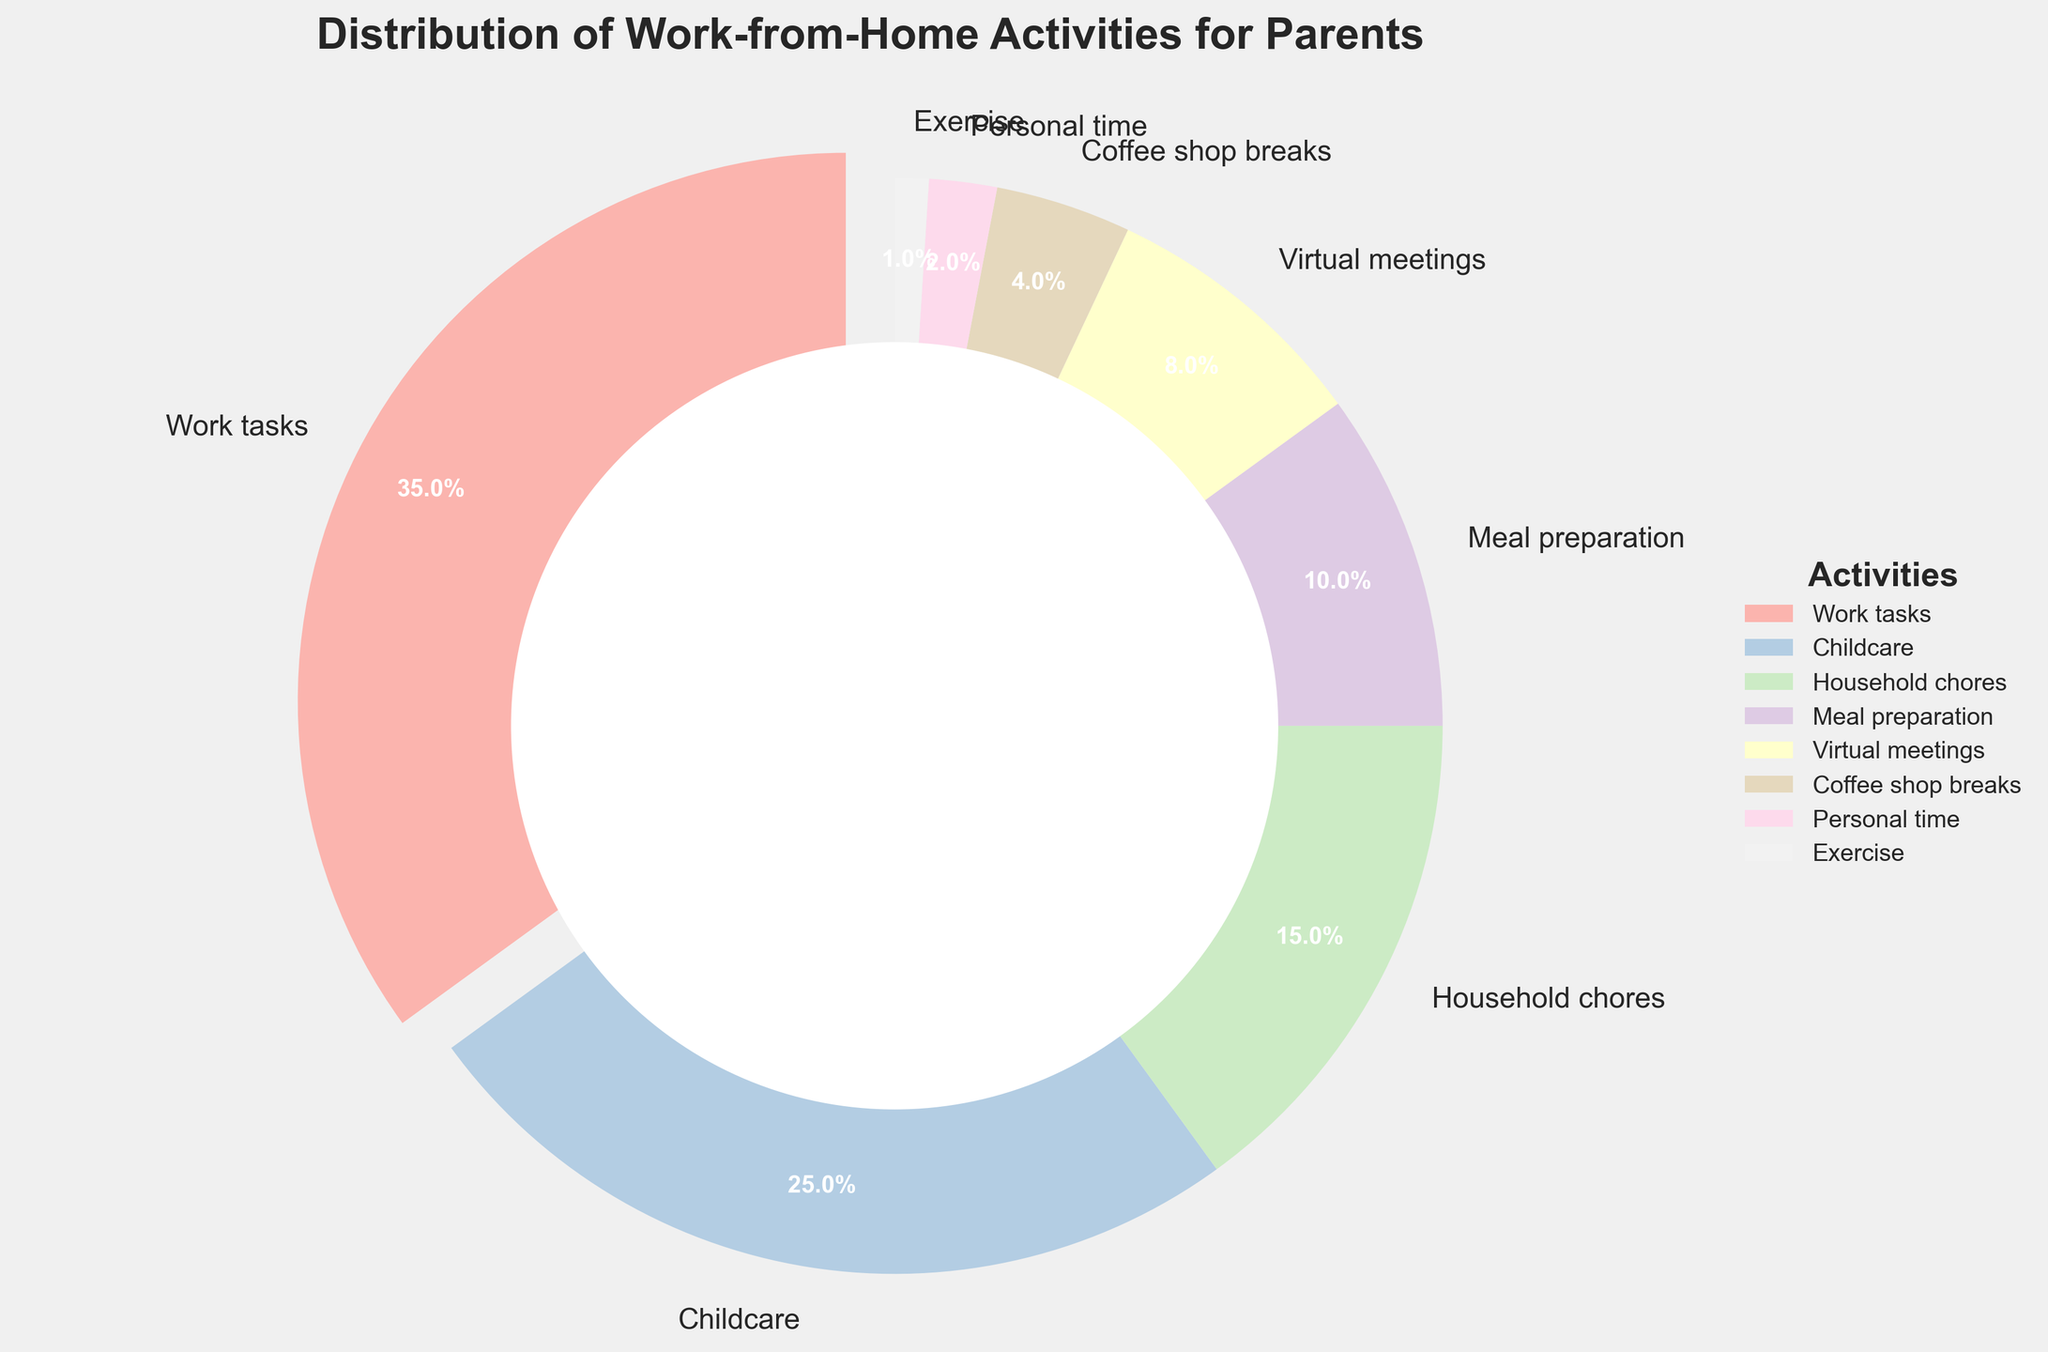What's the largest slice in the pie chart? The largest slice represents the activity with the highest percentage. The slice that stands out the most is for "Work tasks" which is also exploded. It has a percentage of 35%.
Answer: Work tasks What's the smallest slice in the pie chart? The smallest slice represents the activity with the lowest percentage. The thinnest slice is for "Exercise" with only 1%.
Answer: Exercise What's the combined percentage of time spent on childcare and household chores? To find the combined percentage of two activities, sum their individual percentages. For "Childcare" (25%) and "Household chores" (15%): 25% + 15% = 40%.
Answer: 40% Which activity has a slightly larger percentage than meal preparation but less than household chores? Compare the percentages of "Meal preparation" (10%) and "Household chores" (15%) within the range. "Virtual meetings" fits this criterion with 8%, which is slightly less than meal preparation.
Answer: Virtual meetings Which activity do parents spend more time on, virtual meetings or coffee shop breaks? Compare the individual percentages of both activities. "Virtual meetings" is 8% while "Coffee shop breaks" is 4%. Therefore, parents spend more time on virtual meetings.
Answer: Virtual meetings How much more time is spent on childcare than meal preparation? Subtract the percentage of time spent on meal preparation from childcare. "Childcare" is 25% and "Meal preparation" is 10%, so the difference is 25% - 10% = 15%.
Answer: 15% What percentage of time is spent on activities other than work tasks, childcare, and household chores? Subtract the combined percentage of these three activities from 100%. Work tasks (35%), Childcare (25%), and Household chores (15%) sum up to 75%. 100% - 75% = 25%.
Answer: 25% What is the average percentage of time spent on meals, coffee shop breaks, and personal time? To find the average, sum these percentages and divide by the number of activities. Meal preparation (10%), Coffee shop breaks (4%), Personal time (2%) sum up to 10% + 4% + 2% = 16%. The average is 16% / 3 ≈ 5.33%.
Answer: 5.33% How much time in total is spent on personal time and exercise combined? Sum the percentages of both activities. Personal time (2%) and Exercise (1%) combined are 2% + 1% = 3%.
Answer: 3% Which activities combined make up more than half of the parents' time? Find activities whose combined percentages exceed 50%. Work tasks (35%) and Childcare (25%) together make 35% + 25% = 60%, which is greater than 50%.
Answer: Work tasks and Childcare 